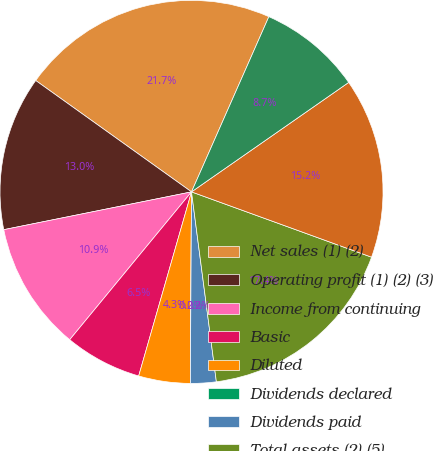Convert chart to OTSL. <chart><loc_0><loc_0><loc_500><loc_500><pie_chart><fcel>Net sales (1) (2)<fcel>Operating profit (1) (2) (3)<fcel>Income from continuing<fcel>Basic<fcel>Diluted<fcel>Dividends declared<fcel>Dividends paid<fcel>Total assets (2) (5)<fcel>Long-term debt (5)<fcel>Shareholders' equity (deficit)<nl><fcel>21.74%<fcel>13.04%<fcel>10.87%<fcel>6.52%<fcel>4.35%<fcel>0.0%<fcel>2.17%<fcel>17.39%<fcel>15.22%<fcel>8.7%<nl></chart> 